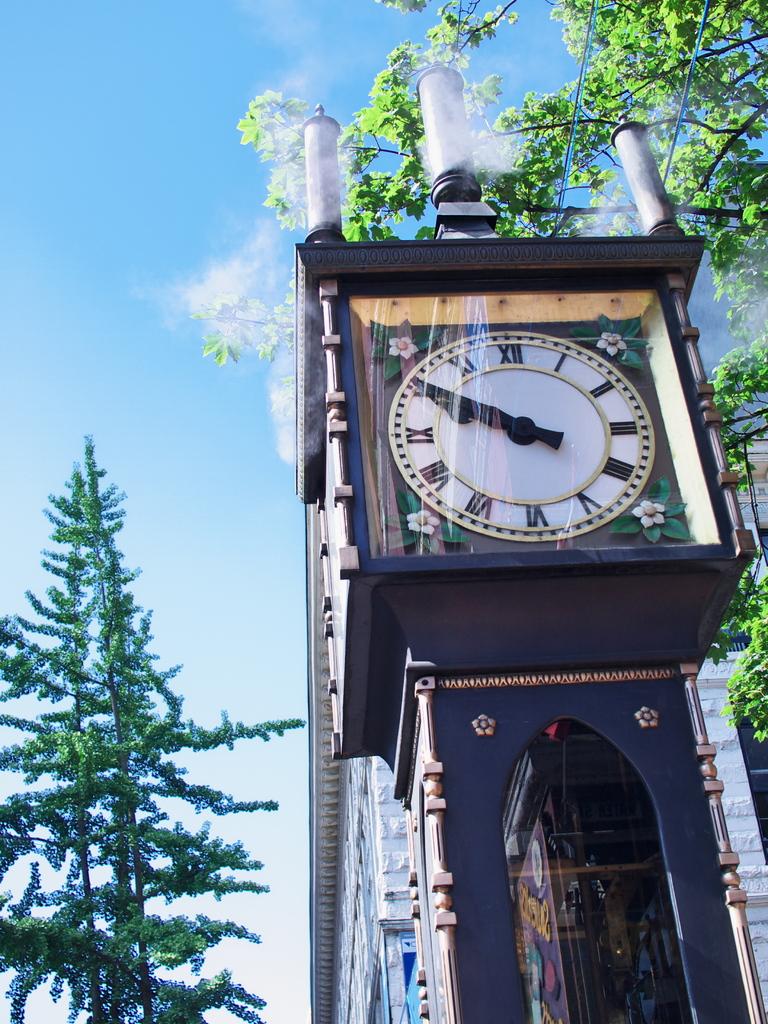What time is shown on the clock?
Keep it short and to the point. 9:50. What number are both hands on?
Offer a very short reply. 10. 